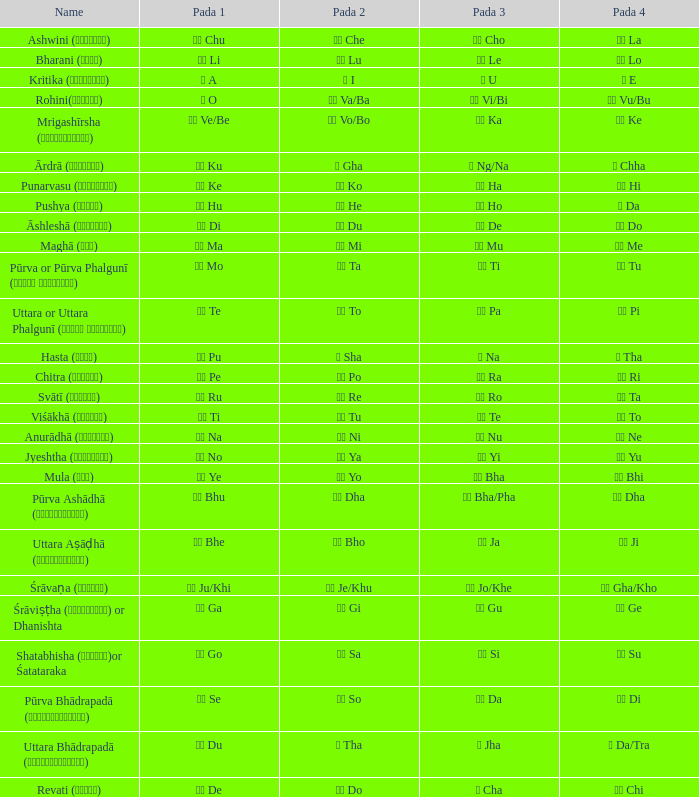Which pada 3 contains a pada 1 of टे te? पा Pa. 